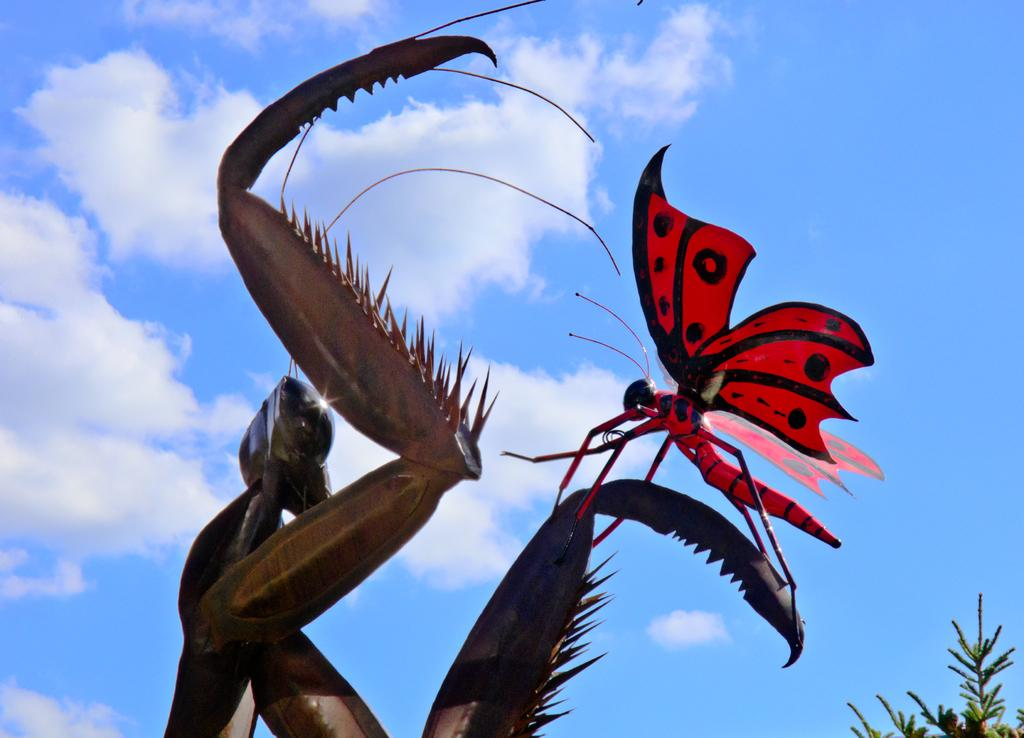What type of animal can be seen in the image? There is a butterfly in the image. What other living organisms are present in the image? There are plants in the image. What can be seen in the background of the image? The sky is visible in the background of the image. What type of butter can be seen on the chessboard in the image? There is no butter or chessboard present in the image; it features a butterfly and plants. Where is the market located in the image? There is no market present in the image. 